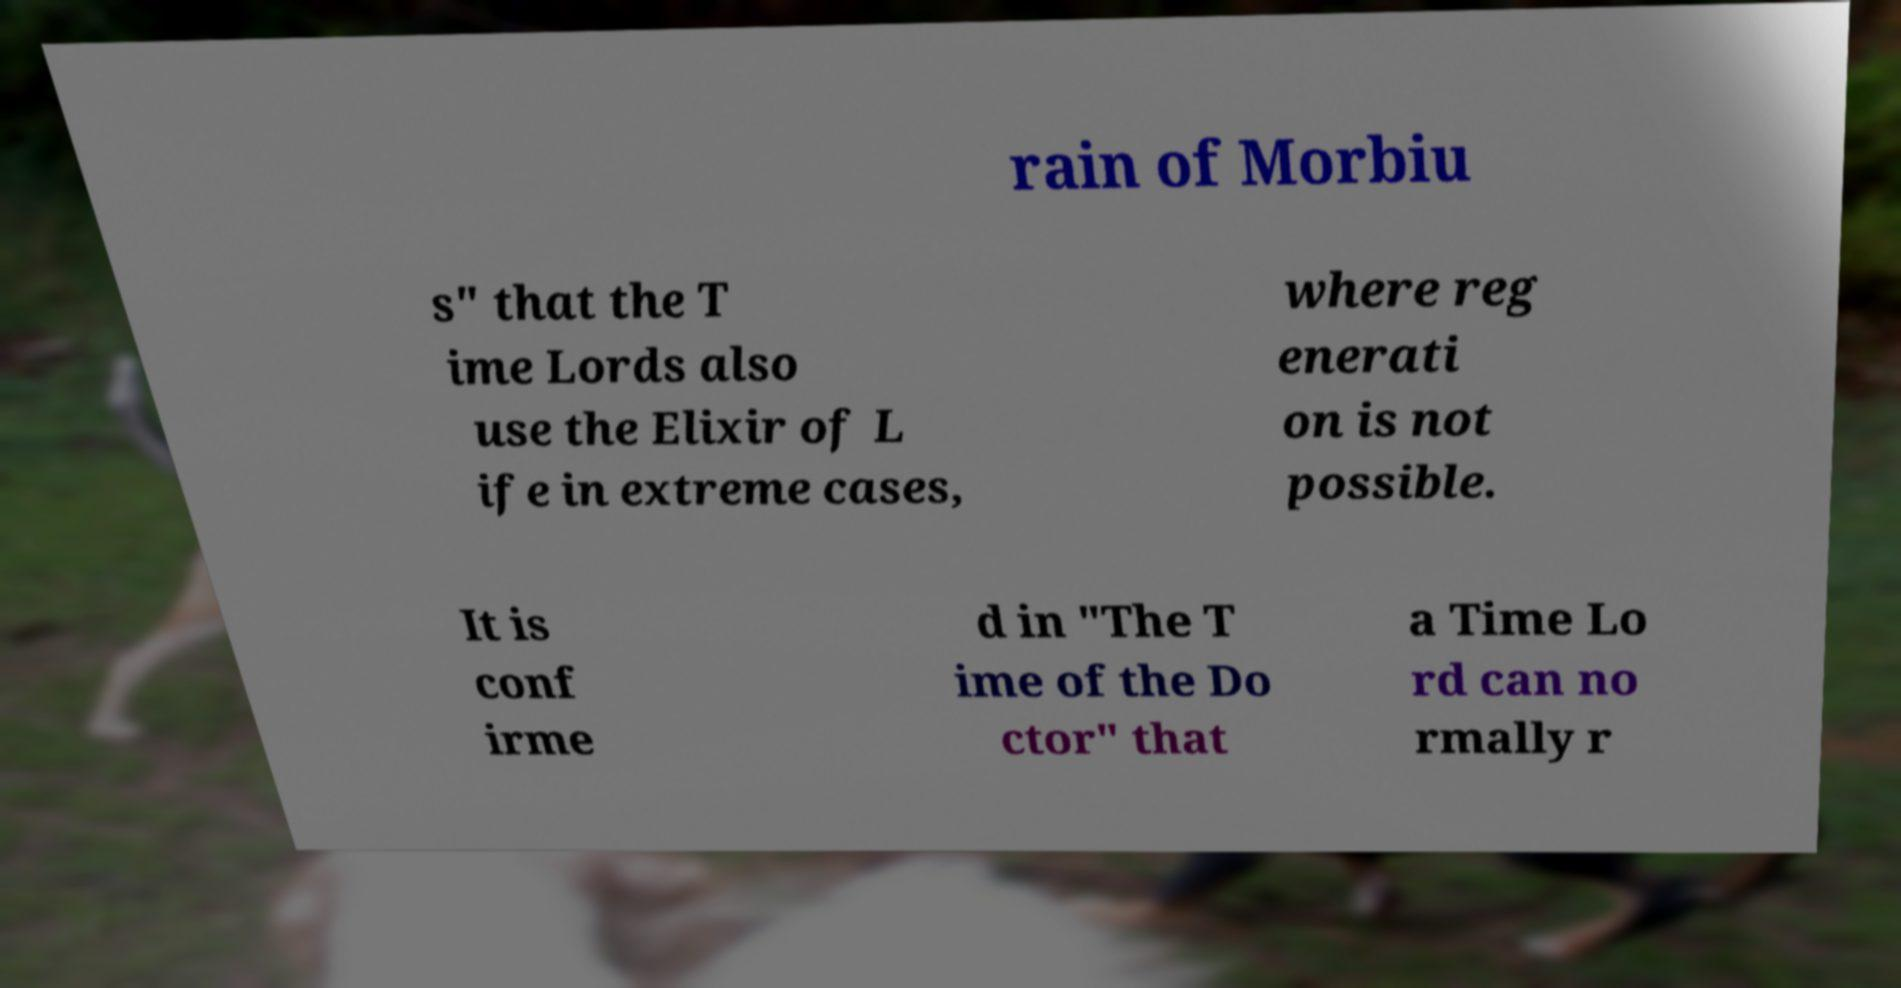Please identify and transcribe the text found in this image. rain of Morbiu s" that the T ime Lords also use the Elixir of L ife in extreme cases, where reg enerati on is not possible. It is conf irme d in "The T ime of the Do ctor" that a Time Lo rd can no rmally r 